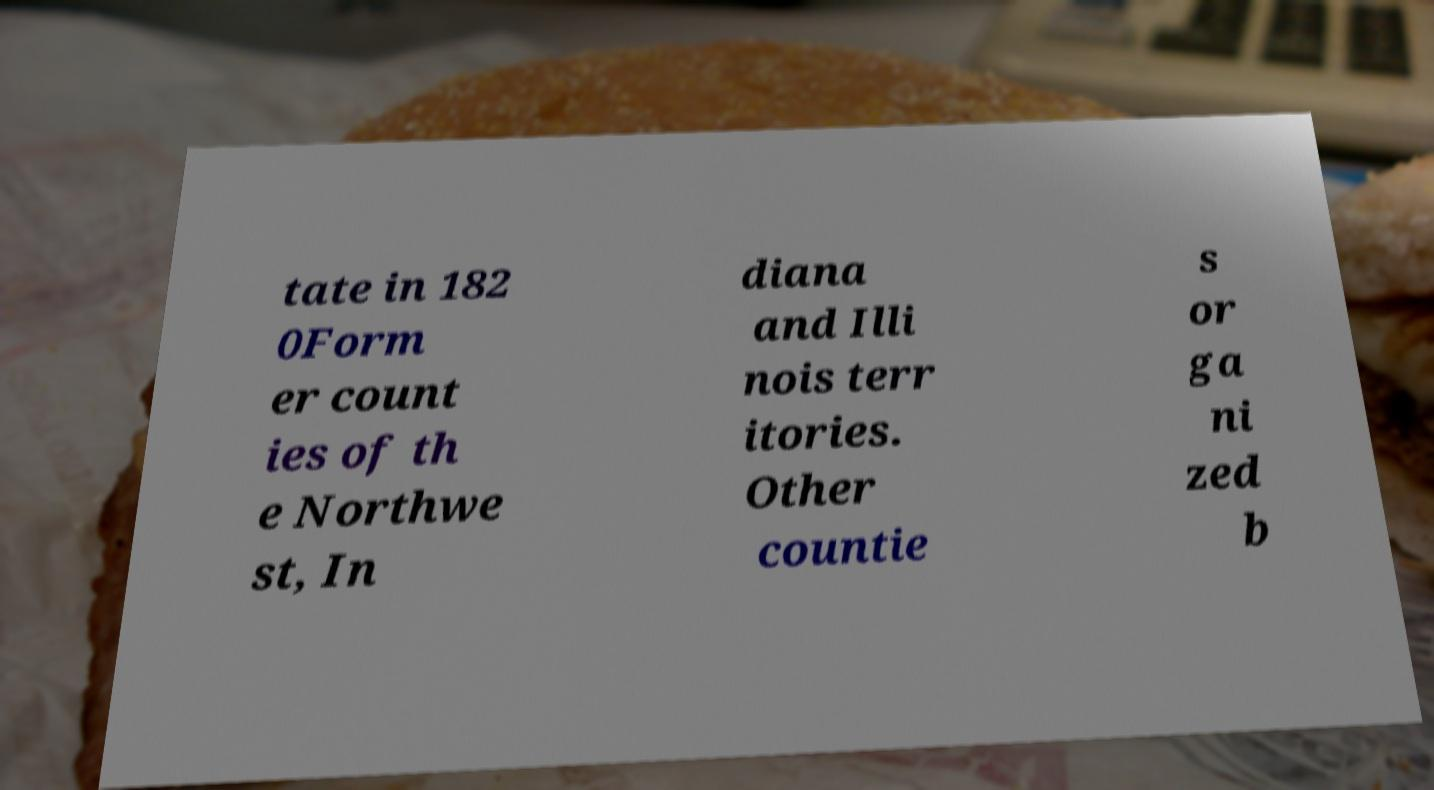I need the written content from this picture converted into text. Can you do that? tate in 182 0Form er count ies of th e Northwe st, In diana and Illi nois terr itories. Other countie s or ga ni zed b 